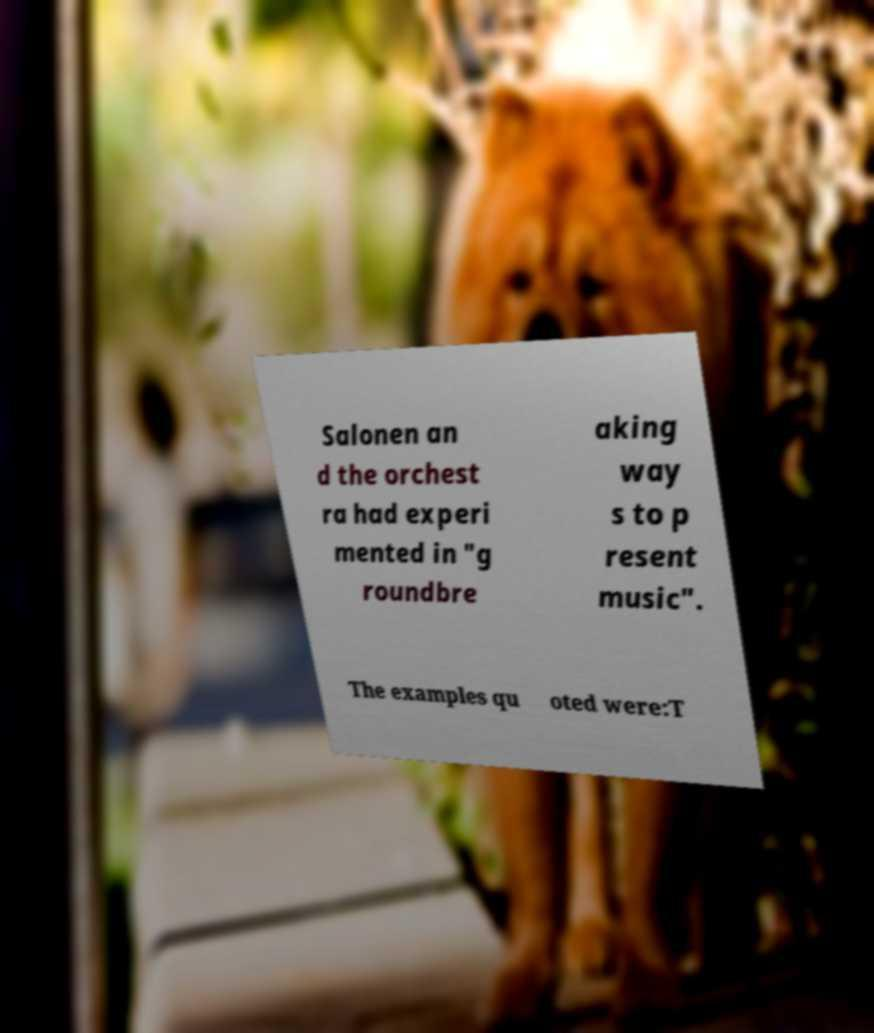Can you read and provide the text displayed in the image?This photo seems to have some interesting text. Can you extract and type it out for me? Salonen an d the orchest ra had experi mented in "g roundbre aking way s to p resent music". The examples qu oted were:T 